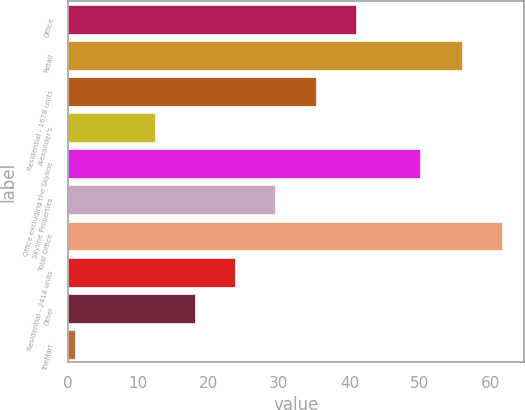Convert chart to OTSL. <chart><loc_0><loc_0><loc_500><loc_500><bar_chart><fcel>Office<fcel>Retail<fcel>Residential - 1678 units<fcel>Alexander's<fcel>Office excluding the Skyline<fcel>Skyline Properties<fcel>Total Office<fcel>Residential - 2414 units<fcel>Other<fcel>theMart<nl><fcel>40.9<fcel>56<fcel>35.2<fcel>12.4<fcel>50<fcel>29.5<fcel>61.7<fcel>23.8<fcel>18.1<fcel>1<nl></chart> 